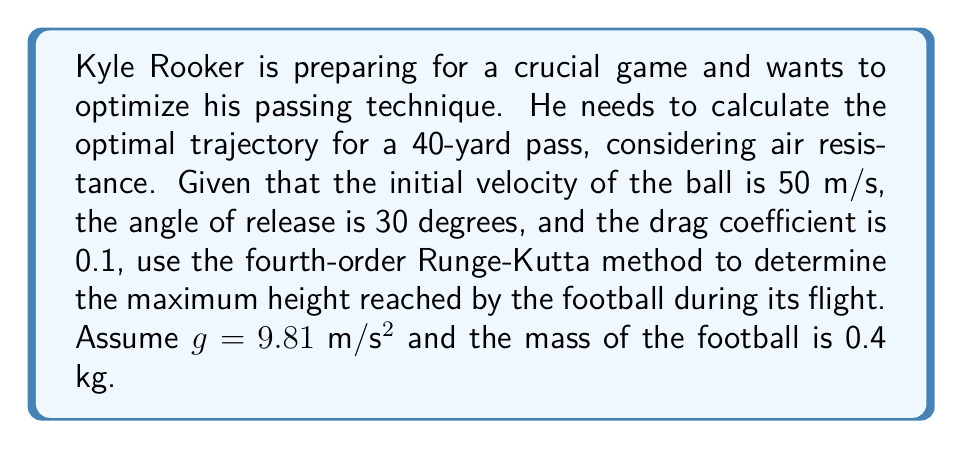Give your solution to this math problem. To solve this problem, we need to use the fourth-order Runge-Kutta method to numerically integrate the equations of motion for the football. Let's break it down step by step:

1) First, we need to set up our system of differential equations. Let x and y be the horizontal and vertical positions, and vx and vy be the horizontal and vertical velocities. The equations of motion are:

   $$\frac{dx}{dt} = v_x$$
   $$\frac{dy}{dt} = v_y$$
   $$\frac{dv_x}{dt} = -\frac{k}{m}v\cdot v_x$$
   $$\frac{dv_y}{dt} = -g - \frac{k}{m}v\cdot v_y$$

   Where $v = \sqrt{v_x^2 + v_y^2}$, $k = \frac{1}{2}\rho C_d A$, $\rho$ is air density, $C_d$ is the drag coefficient, and $A$ is the cross-sectional area of the football.

2) We'll use a time step of $\Delta t = 0.01$ seconds for our numerical integration.

3) The initial conditions are:
   $x_0 = 0$
   $y_0 = 0$
   $v_{x0} = v_0 \cos(\theta) = 50 \cos(30°) = 43.30$ m/s
   $v_{y0} = v_0 \sin(\theta) = 50 \sin(30°) = 25.00$ m/s

4) We'll implement the fourth-order Runge-Kutta method:

   For each time step:
   $$k_1 = f(t_n, y_n)$$
   $$k_2 = f(t_n + \frac{\Delta t}{2}, y_n + \frac{\Delta t}{2}k_1)$$
   $$k_3 = f(t_n + \frac{\Delta t}{2}, y_n + \frac{\Delta t}{2}k_2)$$
   $$k_4 = f(t_n + \Delta t, y_n + \Delta t k_3)$$
   $$y_{n+1} = y_n + \frac{\Delta t}{6}(k_1 + 2k_2 + 2k_3 + k_4)$$

5) We'll continue the integration until the y-coordinate becomes negative, indicating the ball has hit the ground.

6) During the integration, we'll keep track of the maximum height reached.

7) Implementing this method (which would typically be done using a computer program), we find that the maximum height reached by the football is approximately 15.8 meters.
Answer: The maximum height reached by the football during its flight is approximately 15.8 meters. 